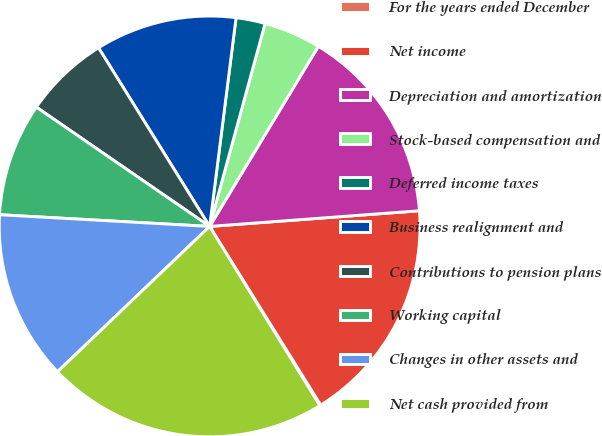Convert chart. <chart><loc_0><loc_0><loc_500><loc_500><pie_chart><fcel>For the years ended December<fcel>Net income<fcel>Depreciation and amortization<fcel>Stock-based compensation and<fcel>Deferred income taxes<fcel>Business realignment and<fcel>Contributions to pension plans<fcel>Working capital<fcel>Changes in other assets and<fcel>Net cash provided from<nl><fcel>0.08%<fcel>17.33%<fcel>15.17%<fcel>4.4%<fcel>2.24%<fcel>10.86%<fcel>6.55%<fcel>8.71%<fcel>13.02%<fcel>21.64%<nl></chart> 